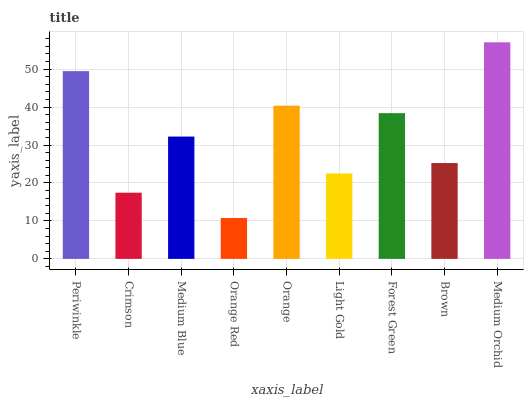Is Orange Red the minimum?
Answer yes or no. Yes. Is Medium Orchid the maximum?
Answer yes or no. Yes. Is Crimson the minimum?
Answer yes or no. No. Is Crimson the maximum?
Answer yes or no. No. Is Periwinkle greater than Crimson?
Answer yes or no. Yes. Is Crimson less than Periwinkle?
Answer yes or no. Yes. Is Crimson greater than Periwinkle?
Answer yes or no. No. Is Periwinkle less than Crimson?
Answer yes or no. No. Is Medium Blue the high median?
Answer yes or no. Yes. Is Medium Blue the low median?
Answer yes or no. Yes. Is Medium Orchid the high median?
Answer yes or no. No. Is Orange Red the low median?
Answer yes or no. No. 